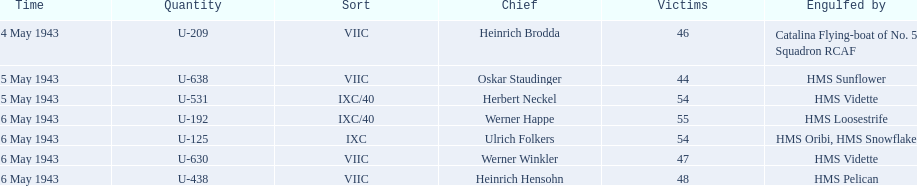What boats were lost on may 5? U-638, U-531. Who were the captains of those boats? Oskar Staudinger, Herbert Neckel. Which captain was not oskar staudinger? Herbert Neckel. 